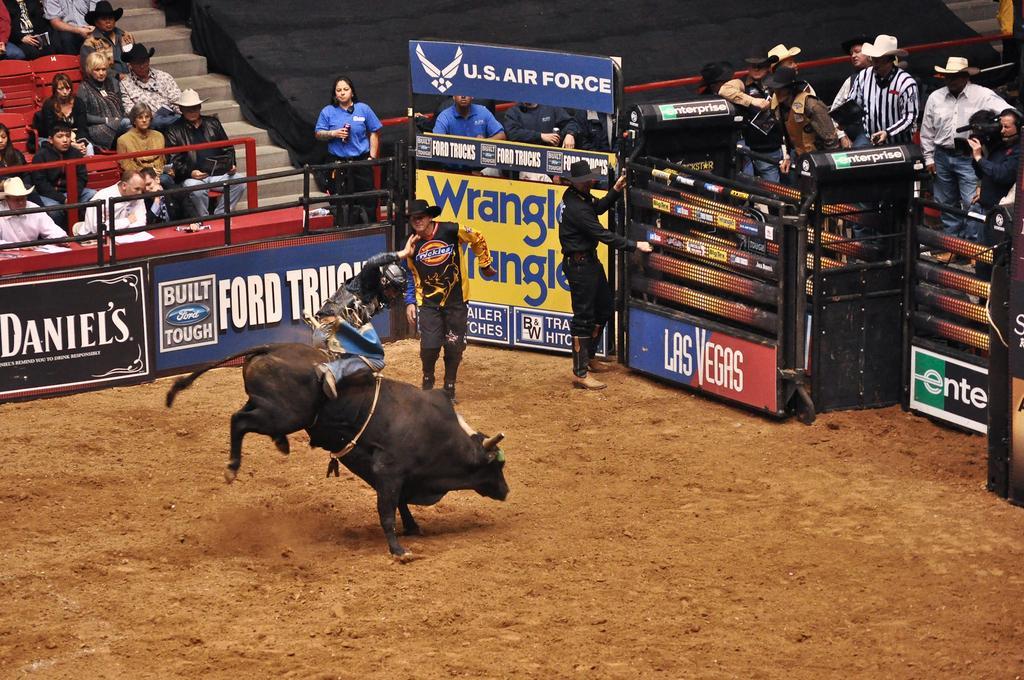Describe this image in one or two sentences. In this picture we can observe a bull which is in black color. There are three members on the ground. We can observe some people sitting behind the railing. There are some people standing on the right side wearing white color hats on their heads. There is a black color cloth in the background. 